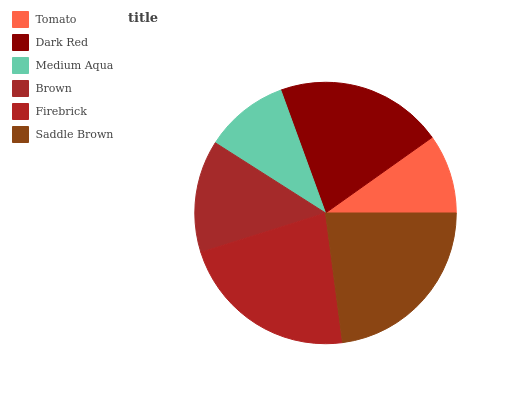Is Tomato the minimum?
Answer yes or no. Yes. Is Saddle Brown the maximum?
Answer yes or no. Yes. Is Dark Red the minimum?
Answer yes or no. No. Is Dark Red the maximum?
Answer yes or no. No. Is Dark Red greater than Tomato?
Answer yes or no. Yes. Is Tomato less than Dark Red?
Answer yes or no. Yes. Is Tomato greater than Dark Red?
Answer yes or no. No. Is Dark Red less than Tomato?
Answer yes or no. No. Is Dark Red the high median?
Answer yes or no. Yes. Is Brown the low median?
Answer yes or no. Yes. Is Brown the high median?
Answer yes or no. No. Is Firebrick the low median?
Answer yes or no. No. 